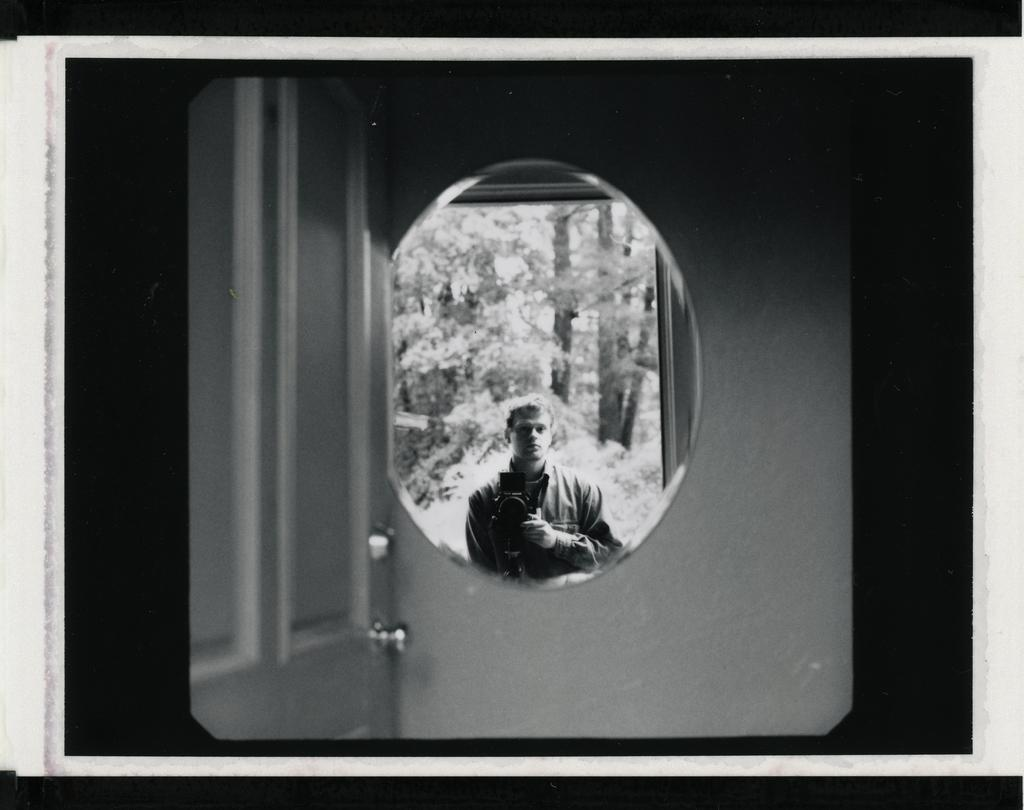What is present in the image? There is a person in the image. What can be seen in addition to the person? The person's reflection is visible on a mirror, and trees are reflected on the mirror as well. How is the mirror positioned in the image? The mirror is hanging on a wall. What other feature can be seen near the mirror? There is a door beside the mirror. Can you see a cat showing disgust with the sticks in the image? There is no cat or sticks present in the image. 